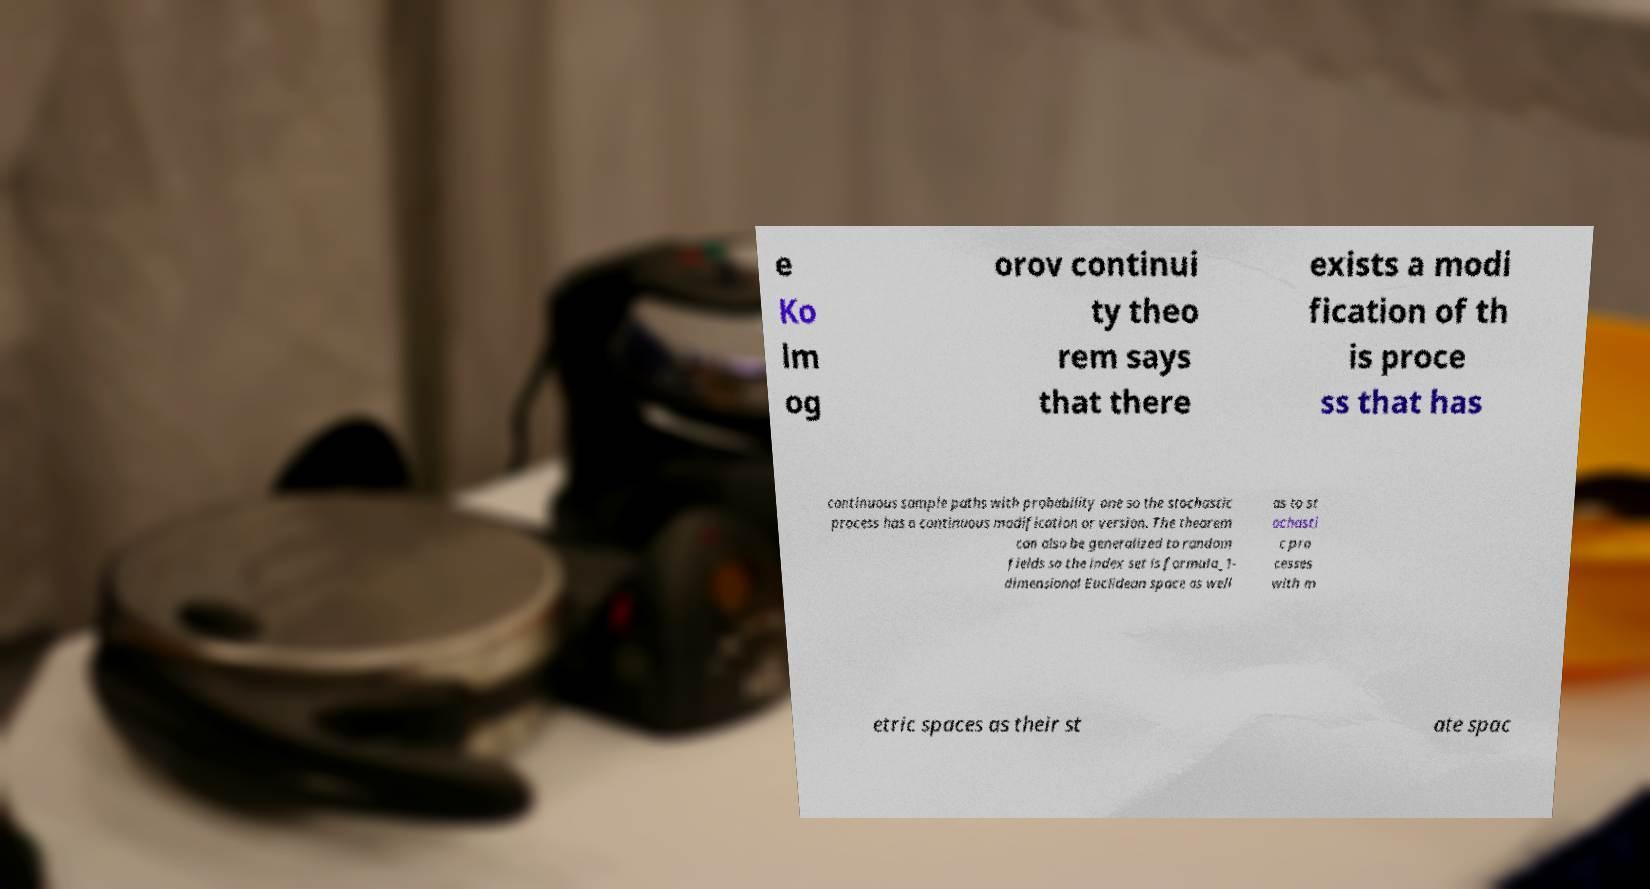I need the written content from this picture converted into text. Can you do that? e Ko lm og orov continui ty theo rem says that there exists a modi fication of th is proce ss that has continuous sample paths with probability one so the stochastic process has a continuous modification or version. The theorem can also be generalized to random fields so the index set is formula_1- dimensional Euclidean space as well as to st ochasti c pro cesses with m etric spaces as their st ate spac 